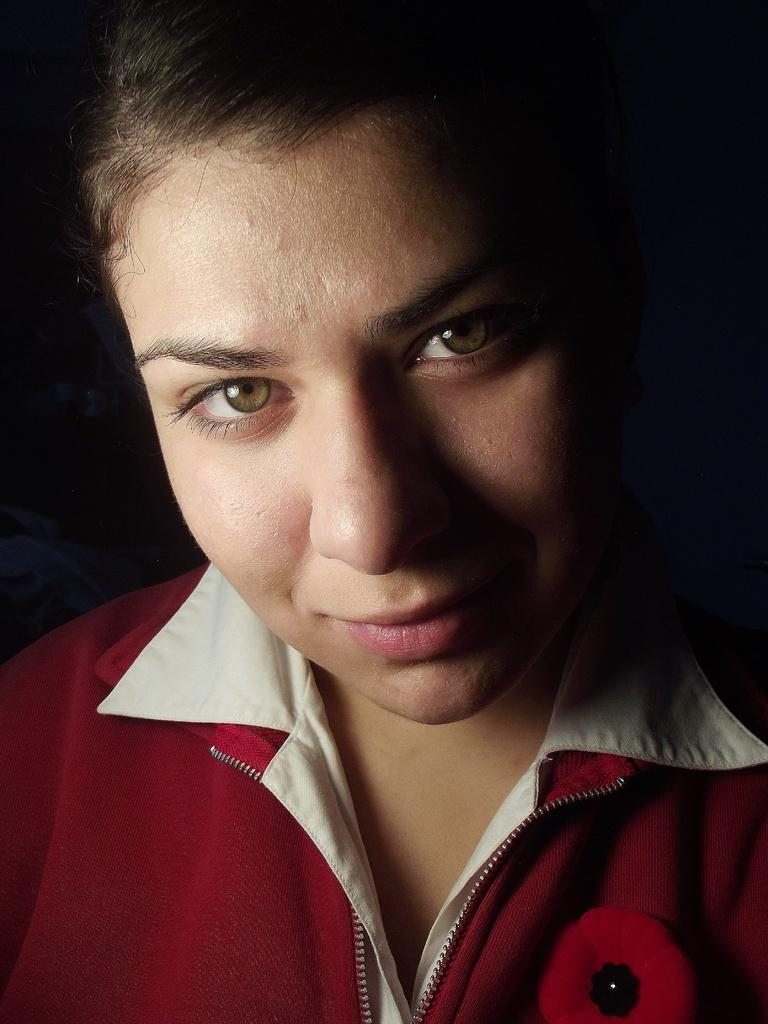What is the woman in the image wearing? The woman is wearing a red dress. What is the woman's facial expression in the image? The woman is smiling. What type of bells can be heard ringing in the image? There are no bells present in the image, and therefore no sound can be heard. 